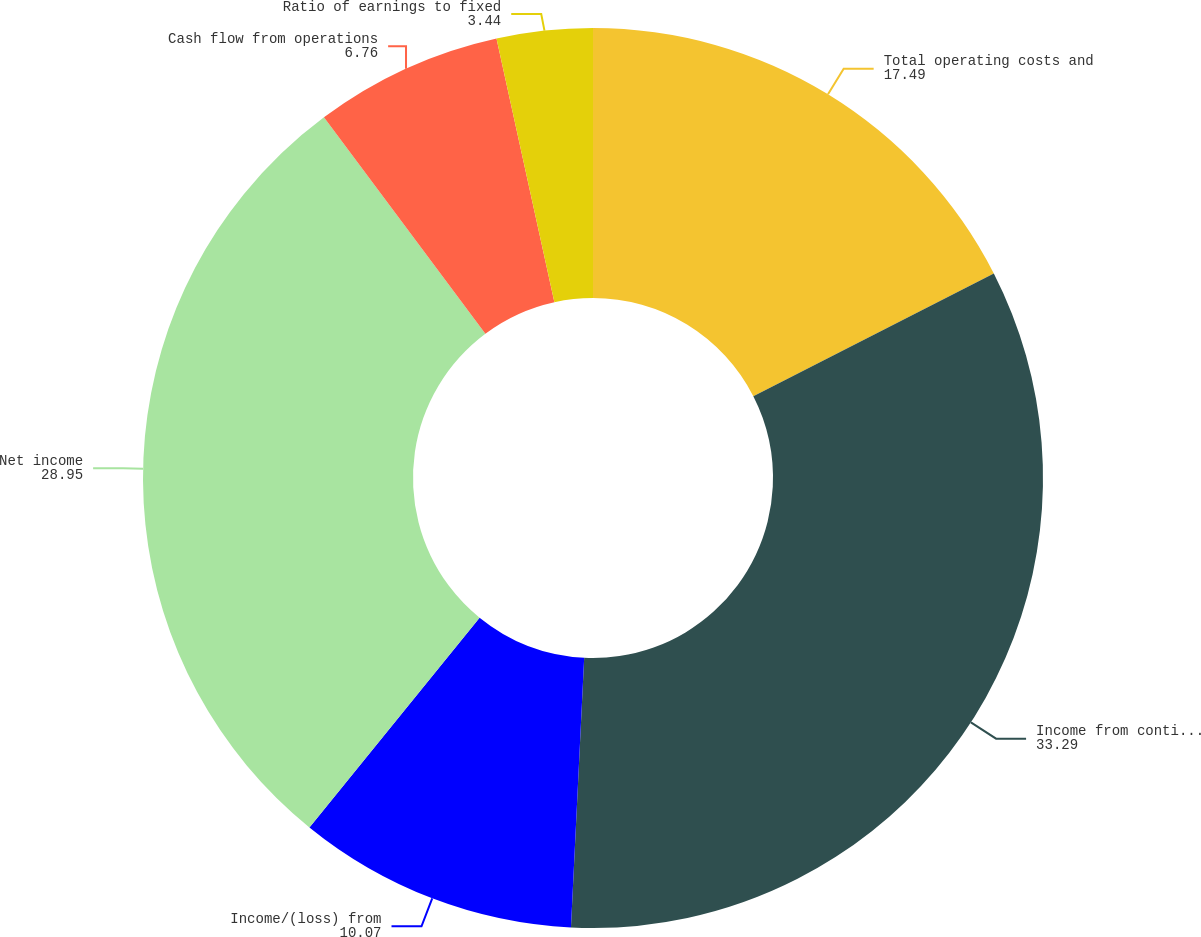Convert chart to OTSL. <chart><loc_0><loc_0><loc_500><loc_500><pie_chart><fcel>Total operating costs and<fcel>Income from continuing<fcel>Income/(loss) from<fcel>Net income<fcel>Cash flow from operations<fcel>Ratio of earnings to fixed<nl><fcel>17.49%<fcel>33.29%<fcel>10.07%<fcel>28.95%<fcel>6.76%<fcel>3.44%<nl></chart> 